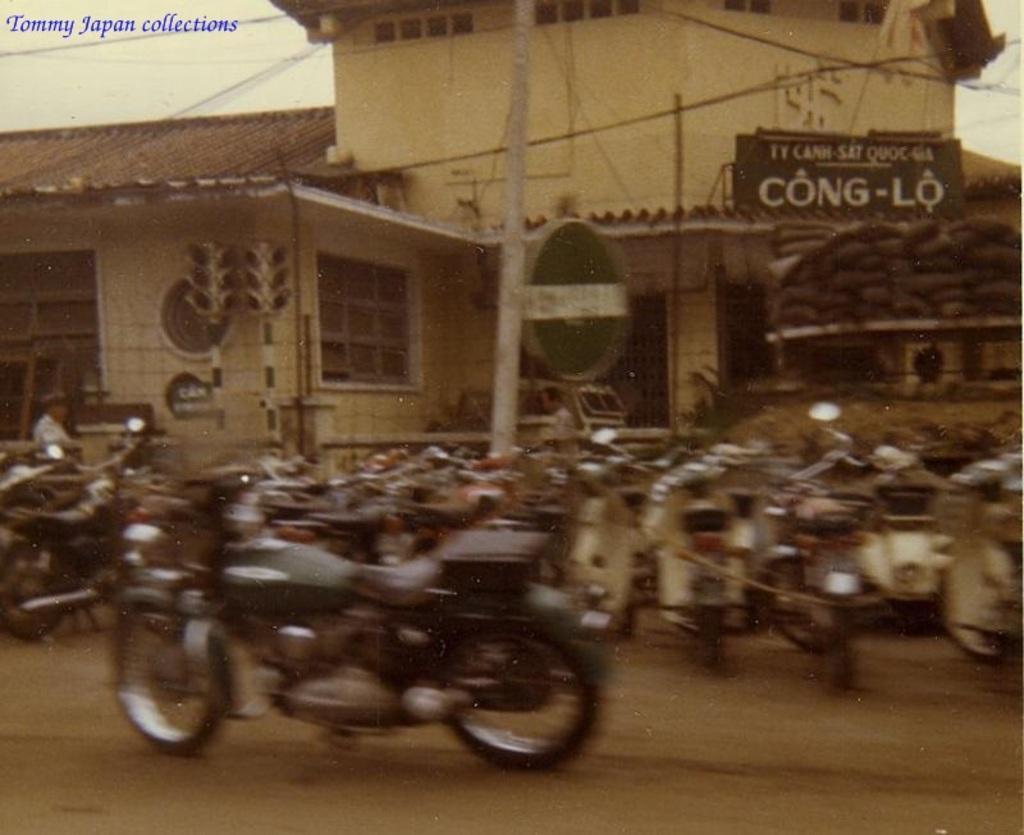Could you give a brief overview of what you see in this image? There are many motorcycles. Also there is a pole. In the background there are buildings. On a building something is written. And there is a watermark on the top left corner. And the image is looking blurred. 